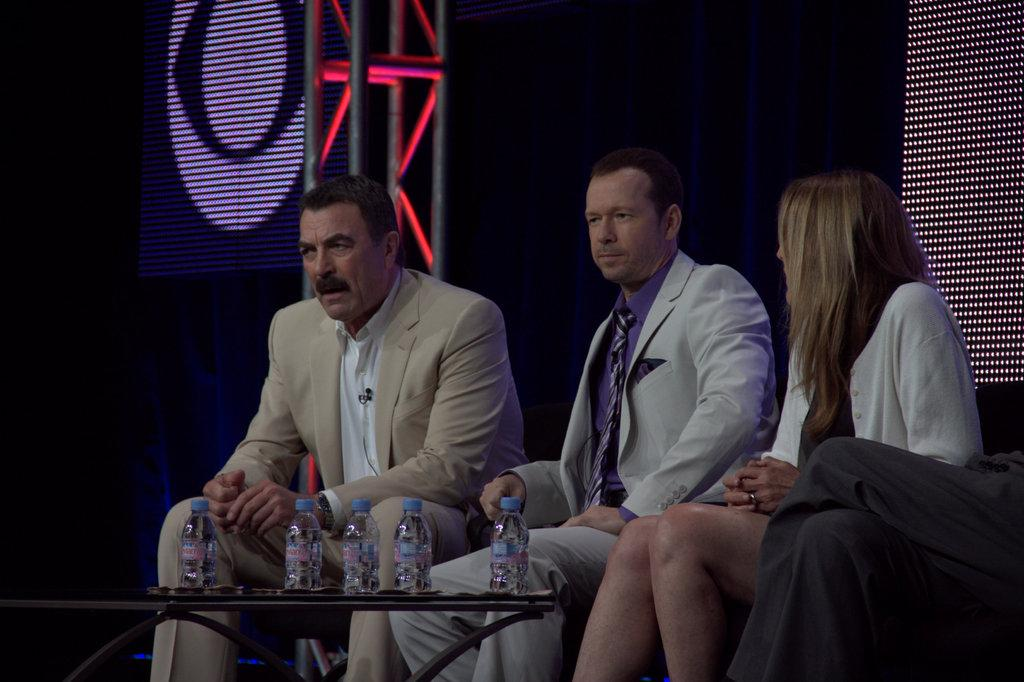How many people are sitting in the image? There are three persons sitting in the image. What can be seen on the table in the image? There are bottles on a table in the image. What is visible in the background of the image? There are lights visible in the background of the image. What year is depicted in the image? There is no specific year depicted in the image; it is a general scene with people, bottles, and lights. How many rings are visible on the fingers of the persons in the image? There is no information about rings on the fingers of the persons in the image; we can only see that they are sitting. 